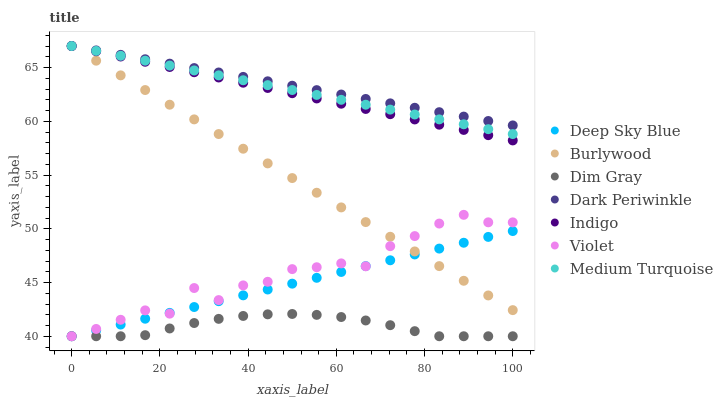Does Dim Gray have the minimum area under the curve?
Answer yes or no. Yes. Does Dark Periwinkle have the maximum area under the curve?
Answer yes or no. Yes. Does Indigo have the minimum area under the curve?
Answer yes or no. No. Does Indigo have the maximum area under the curve?
Answer yes or no. No. Is Medium Turquoise the smoothest?
Answer yes or no. Yes. Is Violet the roughest?
Answer yes or no. Yes. Is Indigo the smoothest?
Answer yes or no. No. Is Indigo the roughest?
Answer yes or no. No. Does Dim Gray have the lowest value?
Answer yes or no. Yes. Does Indigo have the lowest value?
Answer yes or no. No. Does Dark Periwinkle have the highest value?
Answer yes or no. Yes. Does Deep Sky Blue have the highest value?
Answer yes or no. No. Is Dim Gray less than Medium Turquoise?
Answer yes or no. Yes. Is Dark Periwinkle greater than Violet?
Answer yes or no. Yes. Does Medium Turquoise intersect Dark Periwinkle?
Answer yes or no. Yes. Is Medium Turquoise less than Dark Periwinkle?
Answer yes or no. No. Is Medium Turquoise greater than Dark Periwinkle?
Answer yes or no. No. Does Dim Gray intersect Medium Turquoise?
Answer yes or no. No. 